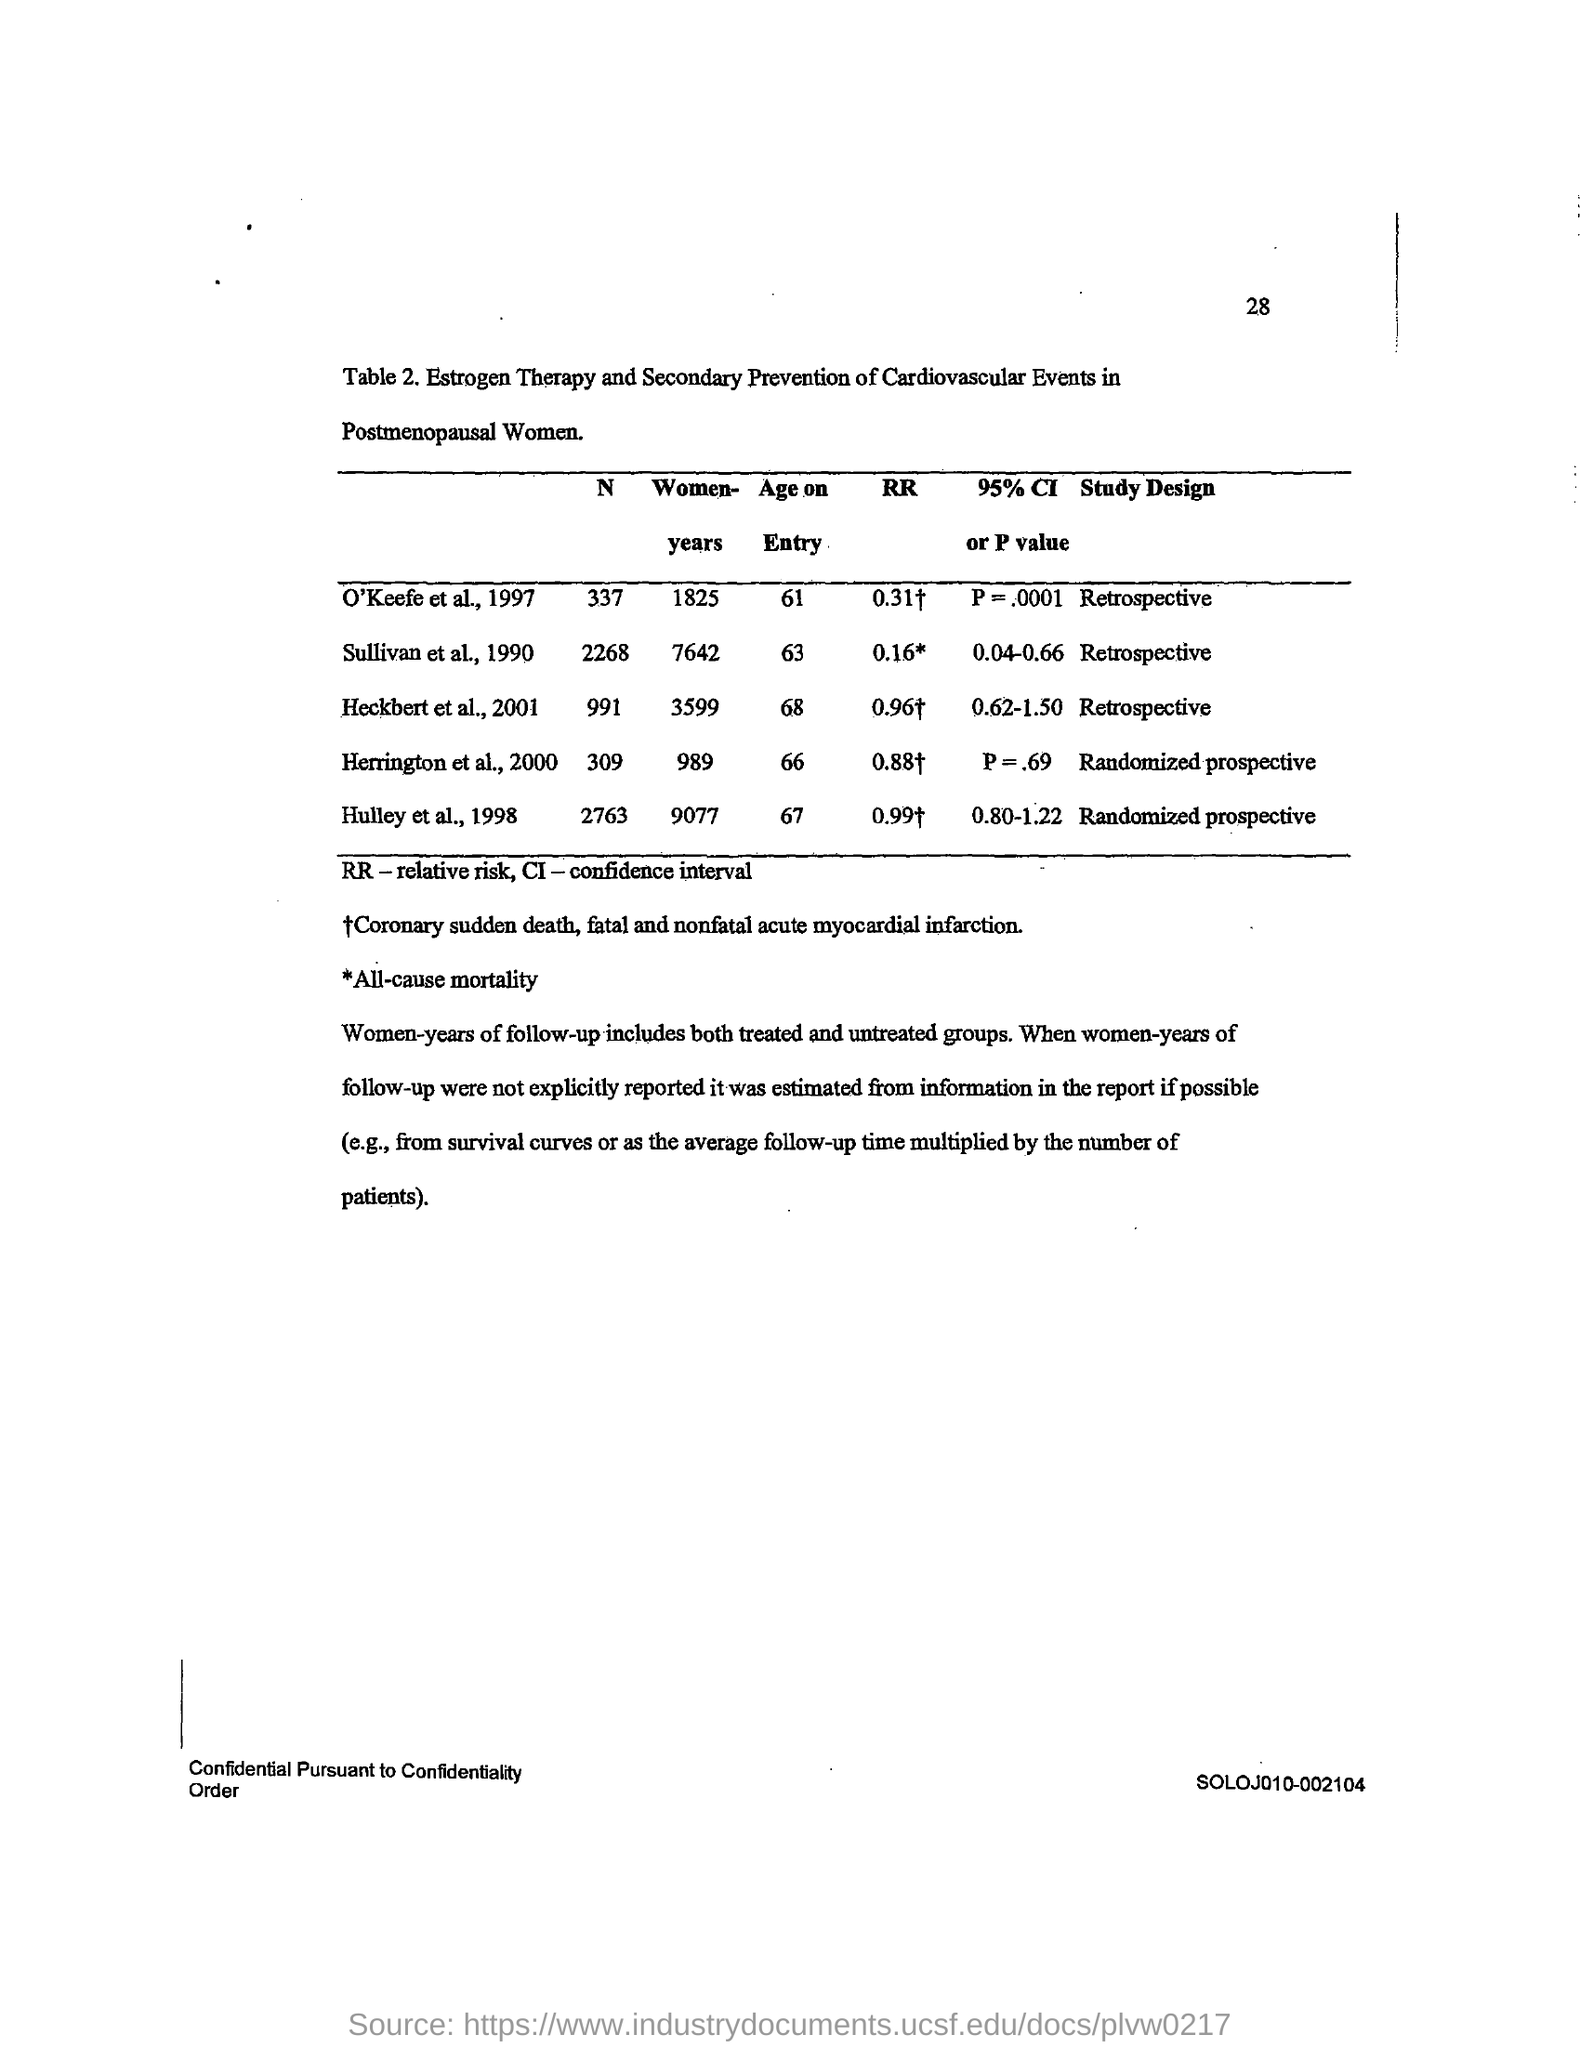Highlight a few significant elements in this photo. The age on entry value for O'Keefe et al.'s study, conducted in 1997, was 61 years old. The study design of Sullivan et al. (1990) was retrospective. The study design for Herrington et al. (2000) is a randomized, prospective study. Relative risk is a measure of the risk of an outcome in an exposed group compared to the risk in a non-exposed group, and is commonly abbreviated as RR. The age at which a person can enter the study being conducted by Heckbert et al. (2001) is 68 years old. 